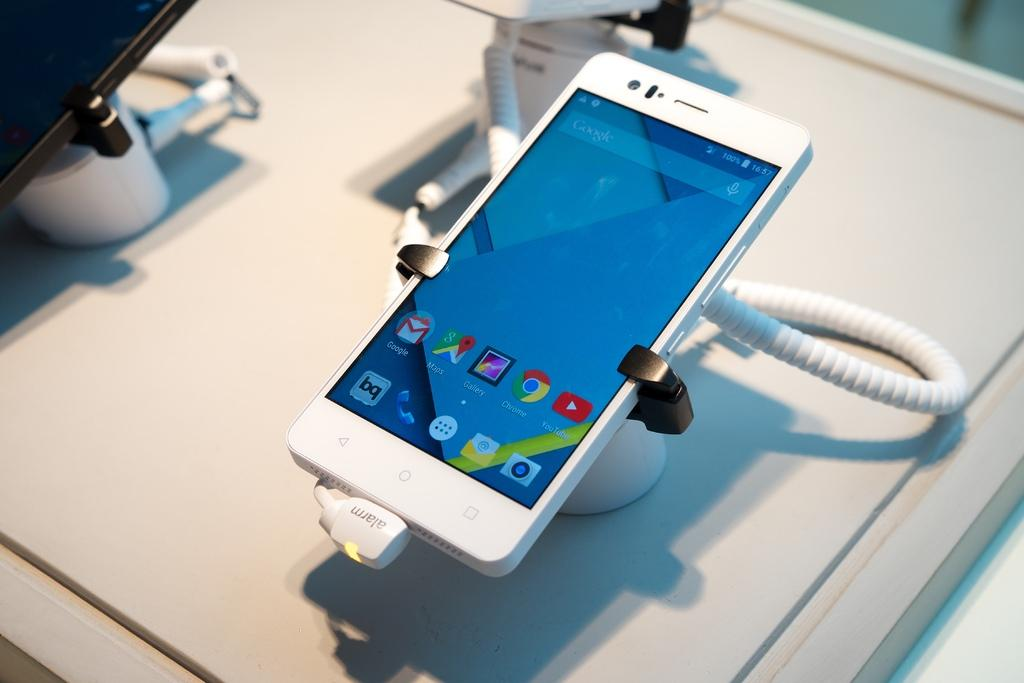<image>
Summarize the visual content of the image. The time is 16:57 and the phone has 100% of its battery power remaining. 